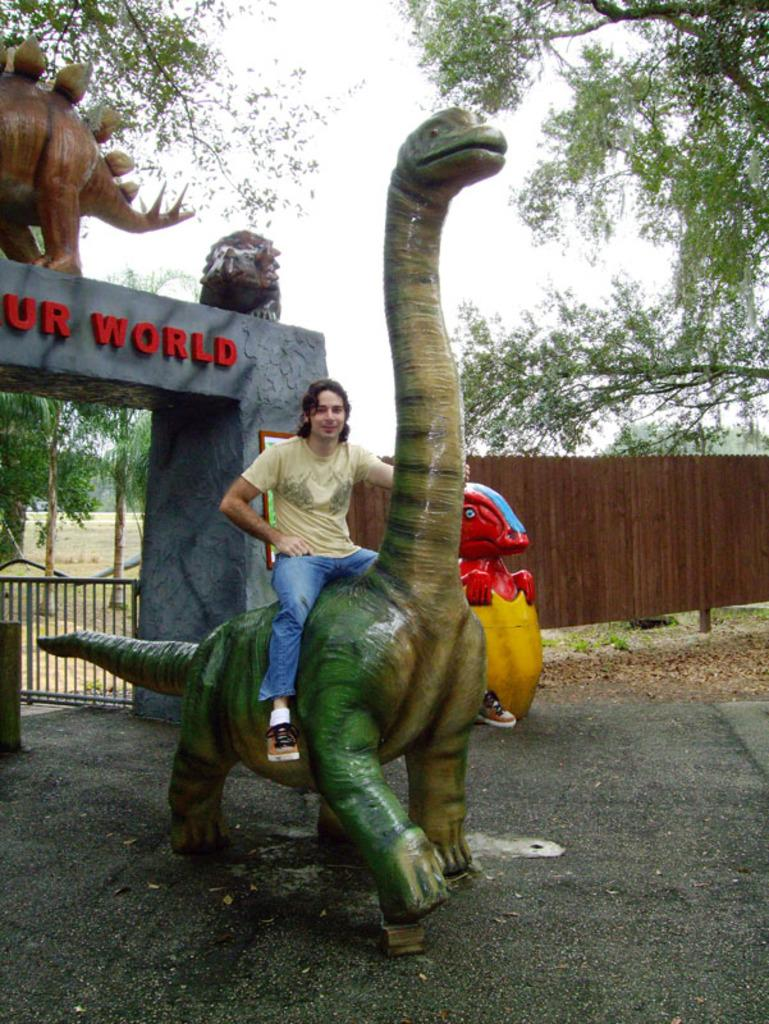What is the man in the image doing? The man is sitting on a sculpture in the image. What structures can be seen on the left side of the image? There is an arch and a gate on the left side of the image. What is visible in the background of the image? There is a fence, trees, and the sky visible in the background of the image. What subject is the man teaching in the image? There is no indication in the image that the man is teaching a subject. How much power does the sculpture have in the image? The sculpture is an inanimate object and does not have any power in the image. 